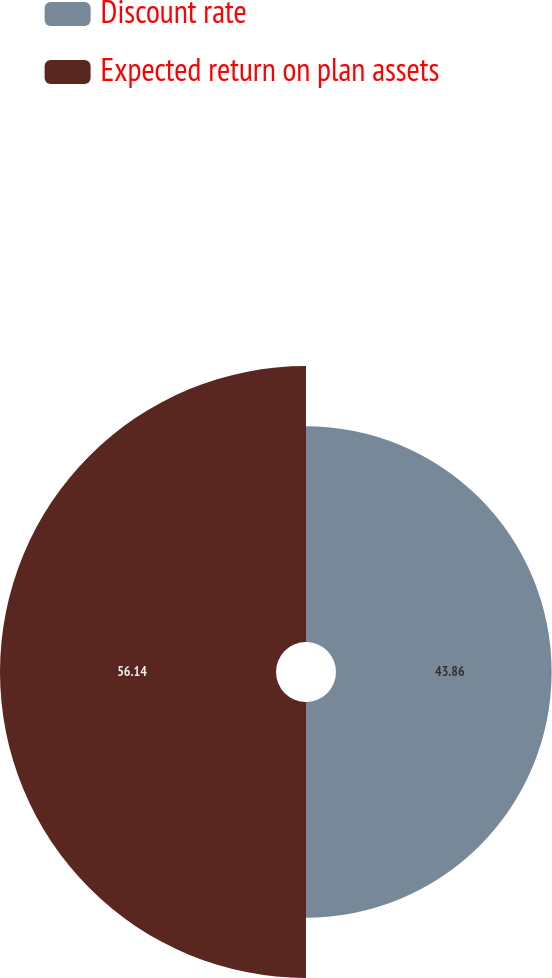Convert chart to OTSL. <chart><loc_0><loc_0><loc_500><loc_500><pie_chart><fcel>Discount rate<fcel>Expected return on plan assets<nl><fcel>43.86%<fcel>56.14%<nl></chart> 